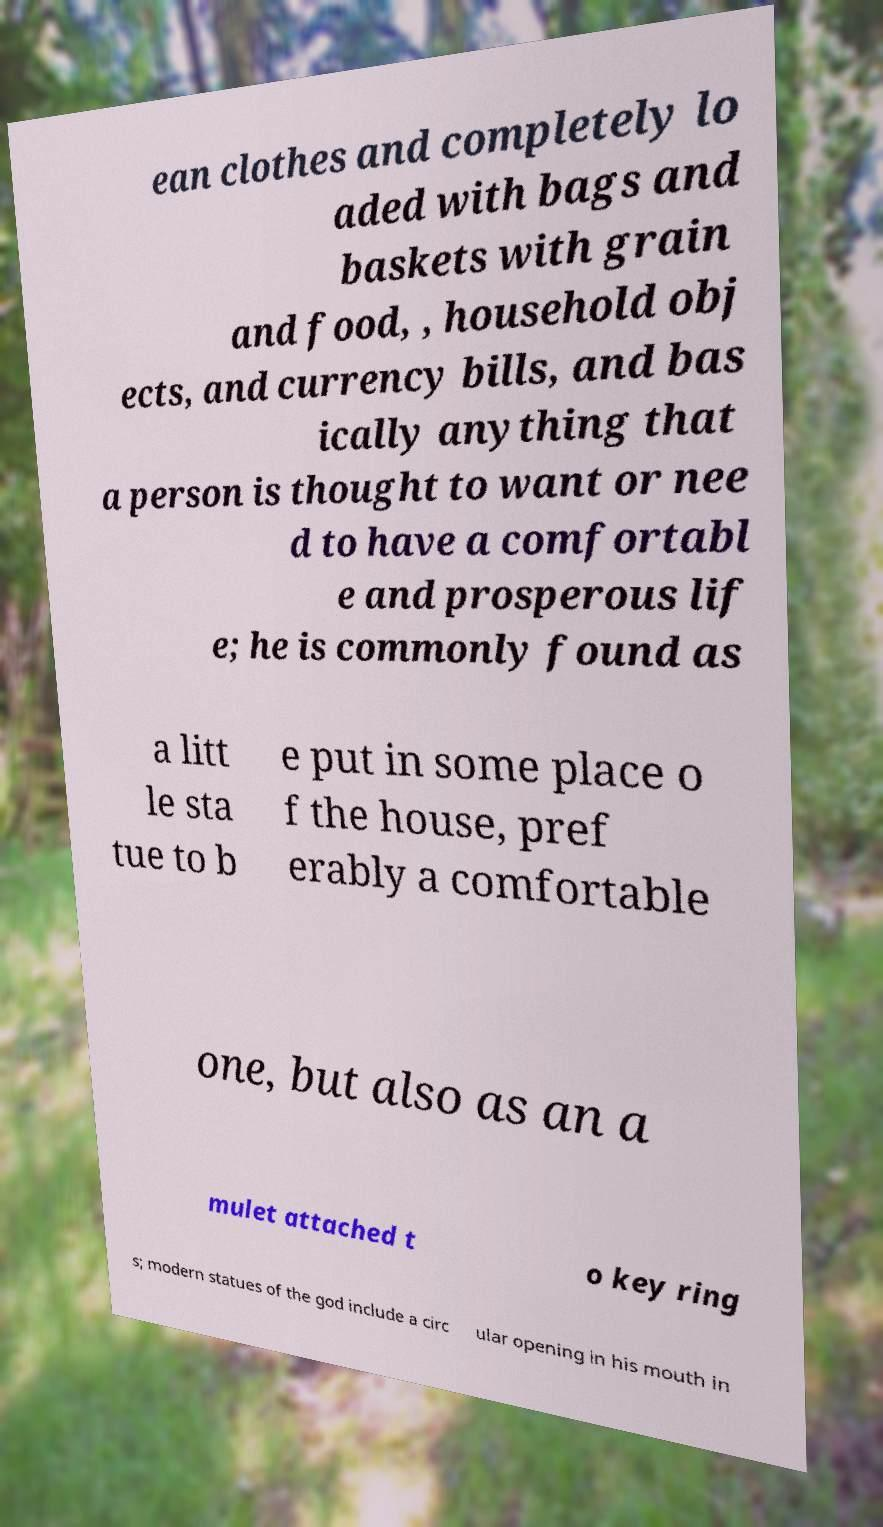For documentation purposes, I need the text within this image transcribed. Could you provide that? ean clothes and completely lo aded with bags and baskets with grain and food, , household obj ects, and currency bills, and bas ically anything that a person is thought to want or nee d to have a comfortabl e and prosperous lif e; he is commonly found as a litt le sta tue to b e put in some place o f the house, pref erably a comfortable one, but also as an a mulet attached t o key ring s; modern statues of the god include a circ ular opening in his mouth in 